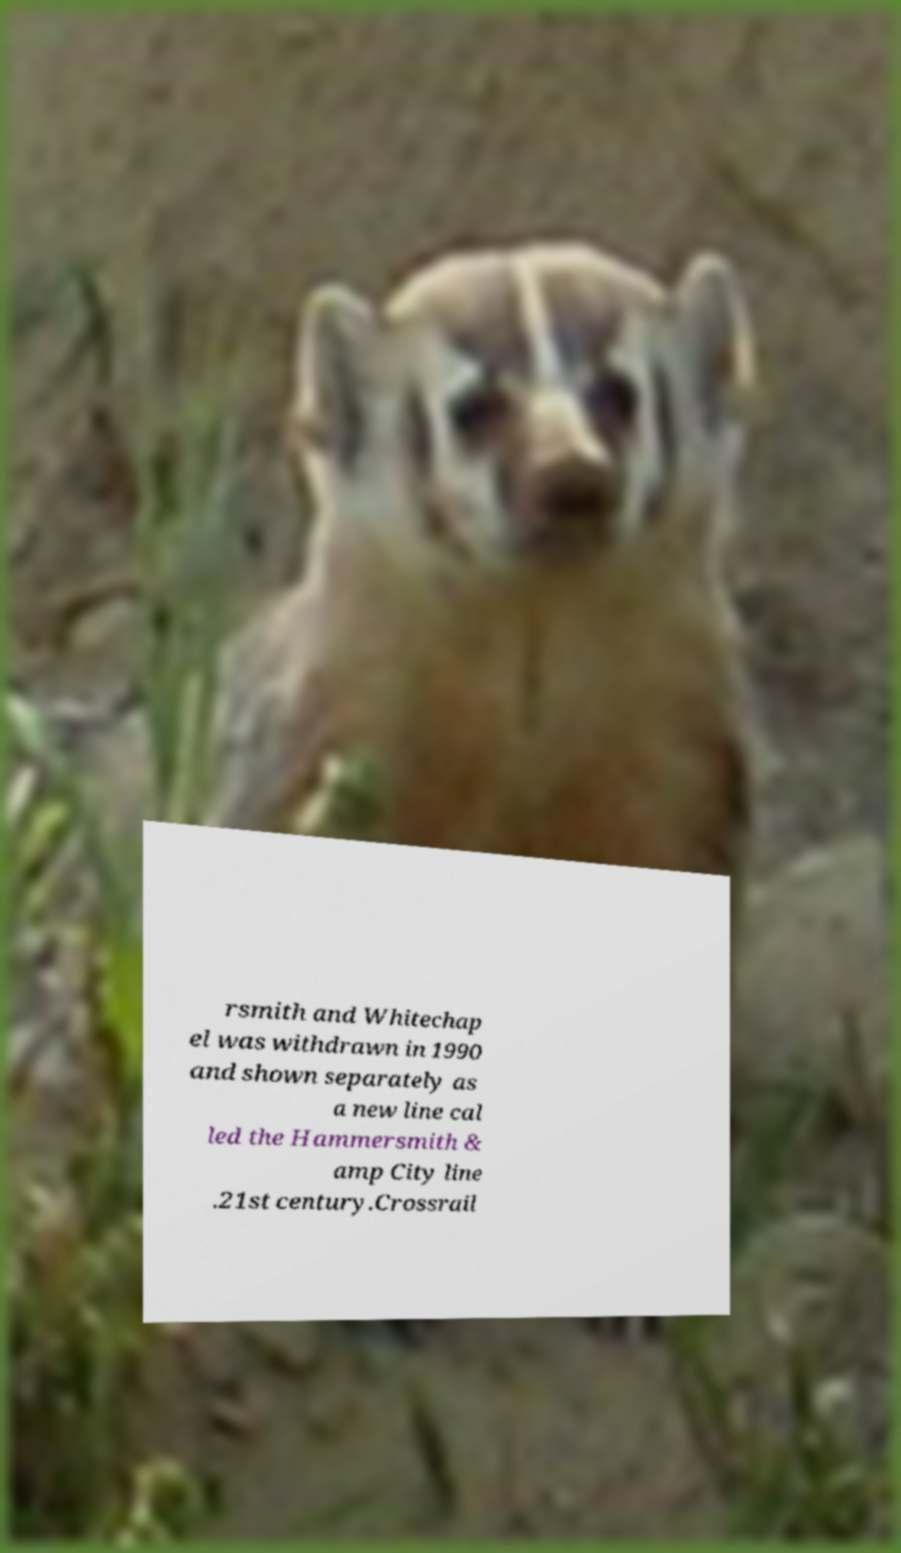What messages or text are displayed in this image? I need them in a readable, typed format. rsmith and Whitechap el was withdrawn in 1990 and shown separately as a new line cal led the Hammersmith & amp City line .21st century.Crossrail 